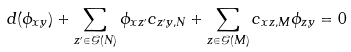<formula> <loc_0><loc_0><loc_500><loc_500>d ( \phi _ { x y } ) + \sum _ { z ^ { \prime } \in \mathcal { G } ( N ) } \phi _ { x z ^ { \prime } } c _ { z ^ { \prime } y , N } + \sum _ { z \in \mathcal { G } ( M ) } c _ { x z , M } \phi _ { z y } = 0</formula> 